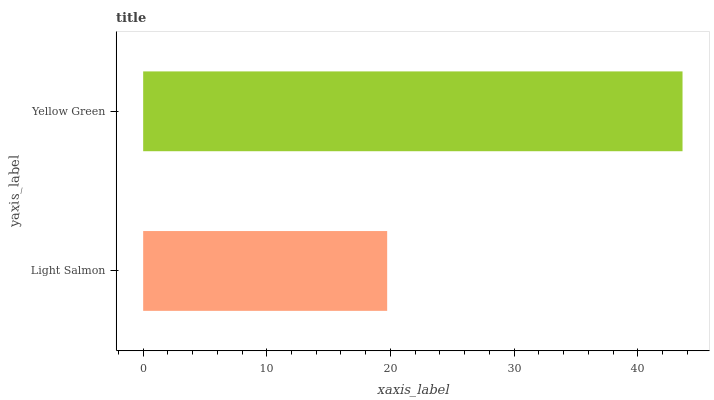Is Light Salmon the minimum?
Answer yes or no. Yes. Is Yellow Green the maximum?
Answer yes or no. Yes. Is Yellow Green the minimum?
Answer yes or no. No. Is Yellow Green greater than Light Salmon?
Answer yes or no. Yes. Is Light Salmon less than Yellow Green?
Answer yes or no. Yes. Is Light Salmon greater than Yellow Green?
Answer yes or no. No. Is Yellow Green less than Light Salmon?
Answer yes or no. No. Is Yellow Green the high median?
Answer yes or no. Yes. Is Light Salmon the low median?
Answer yes or no. Yes. Is Light Salmon the high median?
Answer yes or no. No. Is Yellow Green the low median?
Answer yes or no. No. 